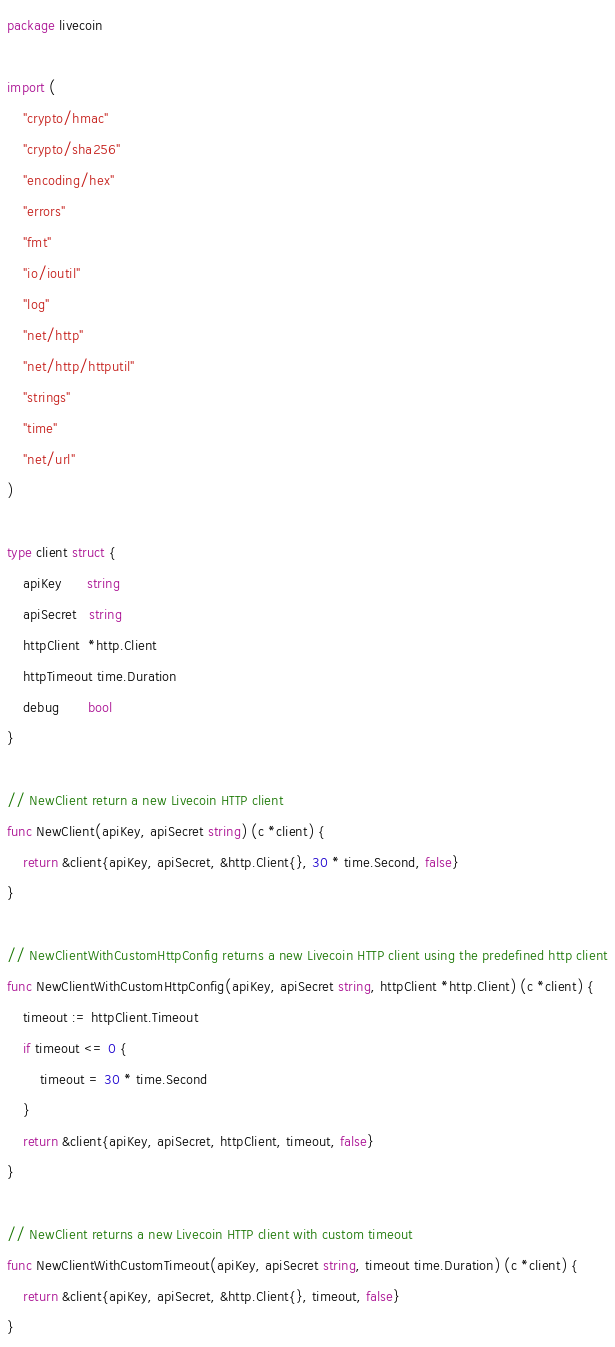Convert code to text. <code><loc_0><loc_0><loc_500><loc_500><_Go_>package livecoin

import (
	"crypto/hmac"
	"crypto/sha256"
	"encoding/hex"
	"errors"
	"fmt"
	"io/ioutil"
	"log"
	"net/http"
	"net/http/httputil"
	"strings"
	"time"
	"net/url"
)

type client struct {
	apiKey      string
	apiSecret   string
	httpClient  *http.Client
	httpTimeout time.Duration
	debug       bool
}

// NewClient return a new Livecoin HTTP client
func NewClient(apiKey, apiSecret string) (c *client) {
	return &client{apiKey, apiSecret, &http.Client{}, 30 * time.Second, false}
}

// NewClientWithCustomHttpConfig returns a new Livecoin HTTP client using the predefined http client
func NewClientWithCustomHttpConfig(apiKey, apiSecret string, httpClient *http.Client) (c *client) {
	timeout := httpClient.Timeout
	if timeout <= 0 {
		timeout = 30 * time.Second
	}
	return &client{apiKey, apiSecret, httpClient, timeout, false}
}

// NewClient returns a new Livecoin HTTP client with custom timeout
func NewClientWithCustomTimeout(apiKey, apiSecret string, timeout time.Duration) (c *client) {
	return &client{apiKey, apiSecret, &http.Client{}, timeout, false}
}
</code> 